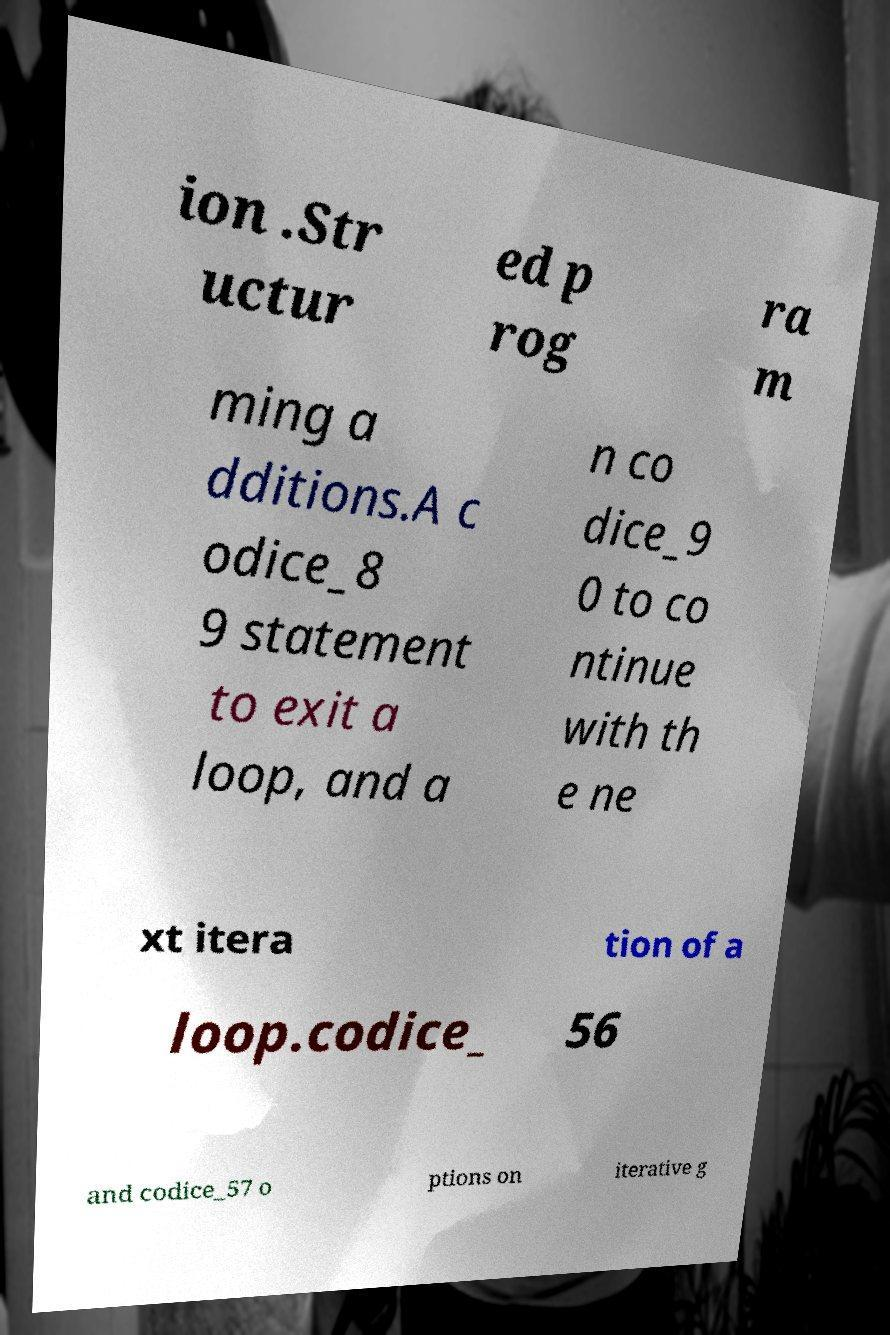Could you extract and type out the text from this image? ion .Str uctur ed p rog ra m ming a dditions.A c odice_8 9 statement to exit a loop, and a n co dice_9 0 to co ntinue with th e ne xt itera tion of a loop.codice_ 56 and codice_57 o ptions on iterative g 